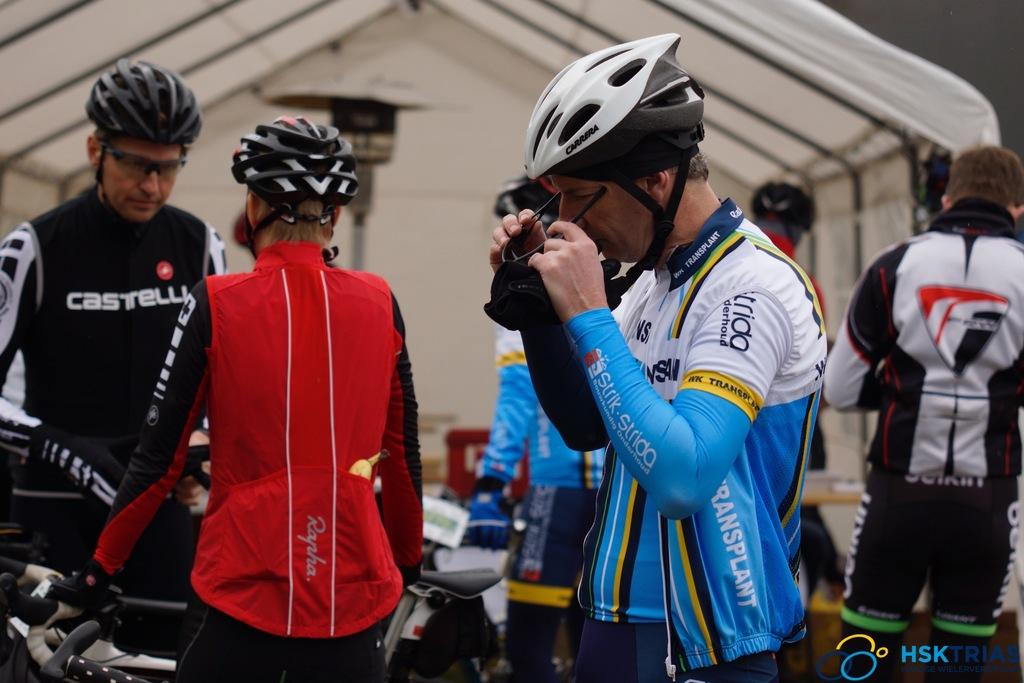What are the people in the center of the image doing? There are persons standing at the bicycles in the center of the image. What can be seen in the background of the image? There is a tent and a person in the background of the image. What type of popcorn is being served at the beach in the image? There is no beach or popcorn present in the image. How is the person in the background tying a knot in the image? There is no person tying a knot in the image. 